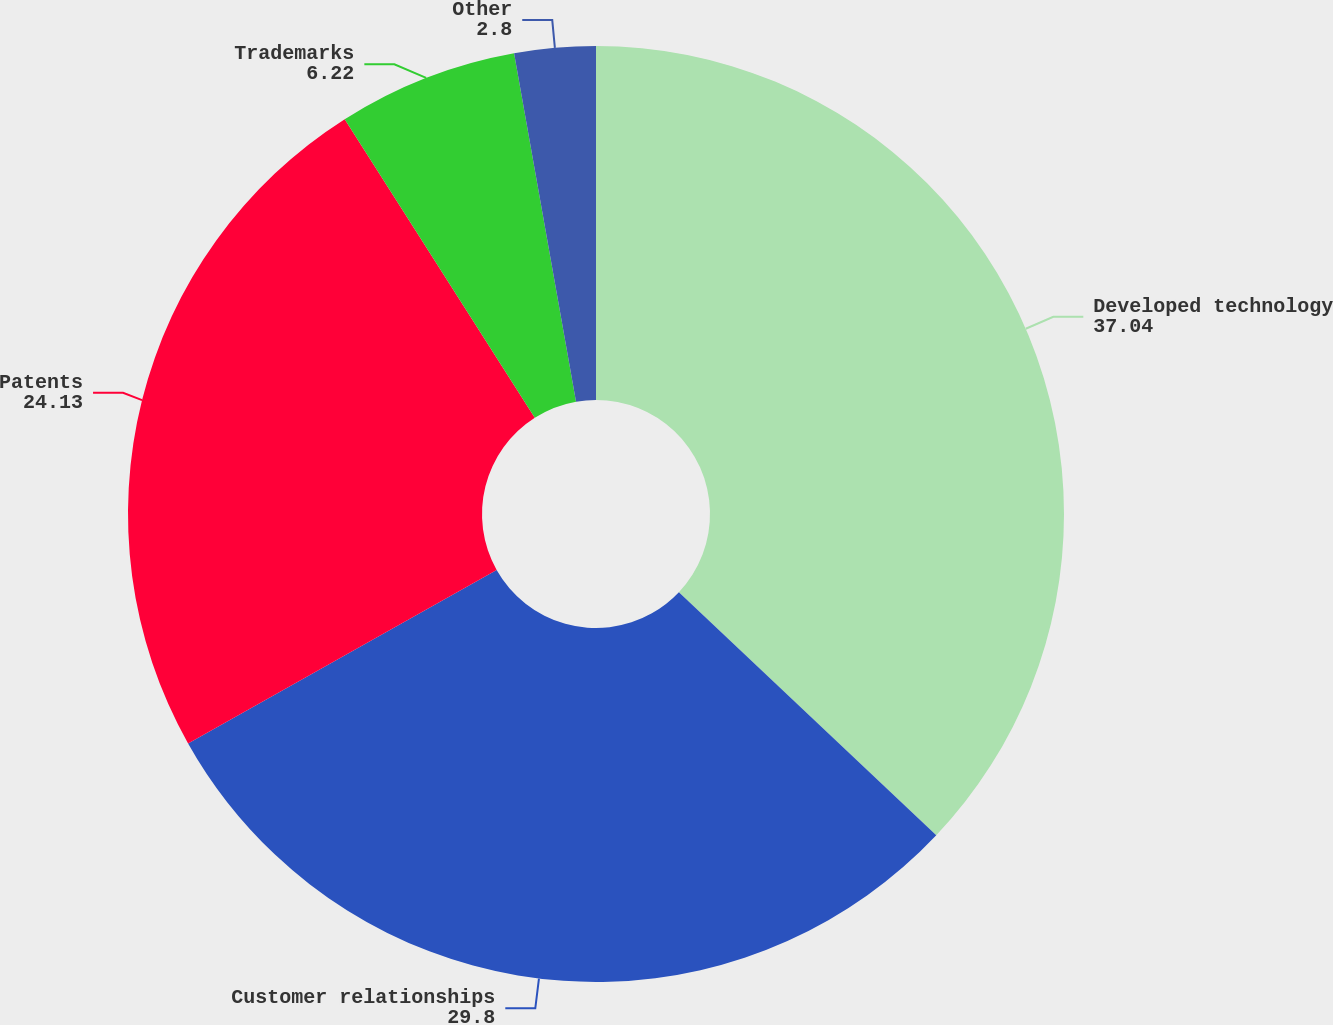Convert chart. <chart><loc_0><loc_0><loc_500><loc_500><pie_chart><fcel>Developed technology<fcel>Customer relationships<fcel>Patents<fcel>Trademarks<fcel>Other<nl><fcel>37.04%<fcel>29.8%<fcel>24.13%<fcel>6.22%<fcel>2.8%<nl></chart> 